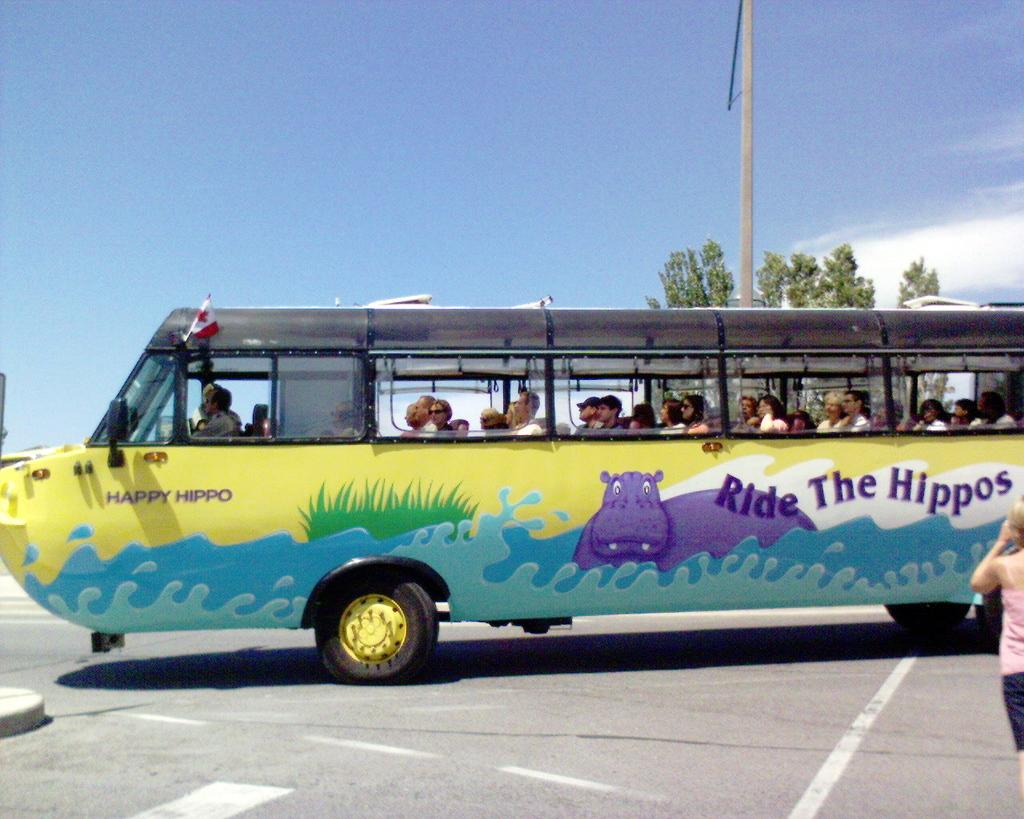Provide a one-sentence caption for the provided image. People riding in a bus that says "Ride The Hippos". 